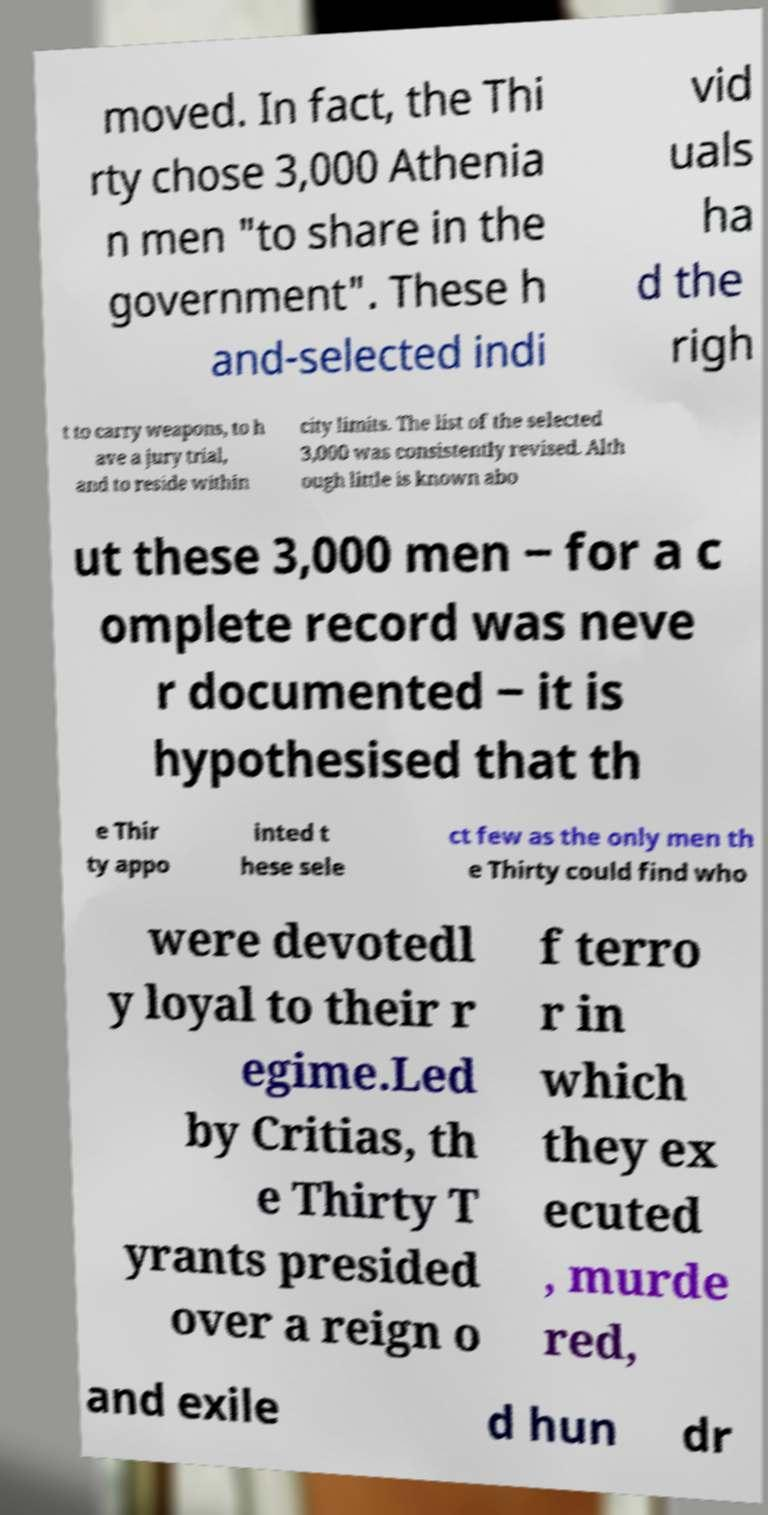For documentation purposes, I need the text within this image transcribed. Could you provide that? moved. In fact, the Thi rty chose 3,000 Athenia n men "to share in the government". These h and-selected indi vid uals ha d the righ t to carry weapons, to h ave a jury trial, and to reside within city limits. The list of the selected 3,000 was consistently revised. Alth ough little is known abo ut these 3,000 men ‒ for a c omplete record was neve r documented ‒ it is hypothesised that th e Thir ty appo inted t hese sele ct few as the only men th e Thirty could find who were devotedl y loyal to their r egime.Led by Critias, th e Thirty T yrants presided over a reign o f terro r in which they ex ecuted , murde red, and exile d hun dr 